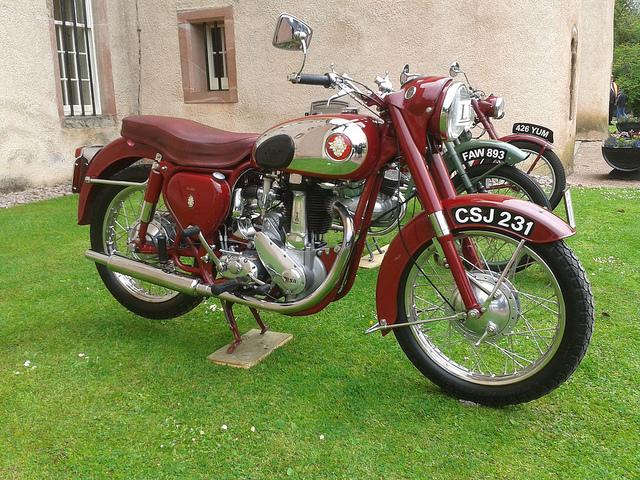What is the color of the window frame?
Be succinct. Brown. What number is on the side of the bike?
Keep it brief. 231. What is the number on the bike?
Answer briefly. 231. What is written on the bikes wheel?
Short answer required. Csj231. How are the bikes standing straight up?
Quick response, please. Kickstand. How many bikes are the same color?
Give a very brief answer. 2. 